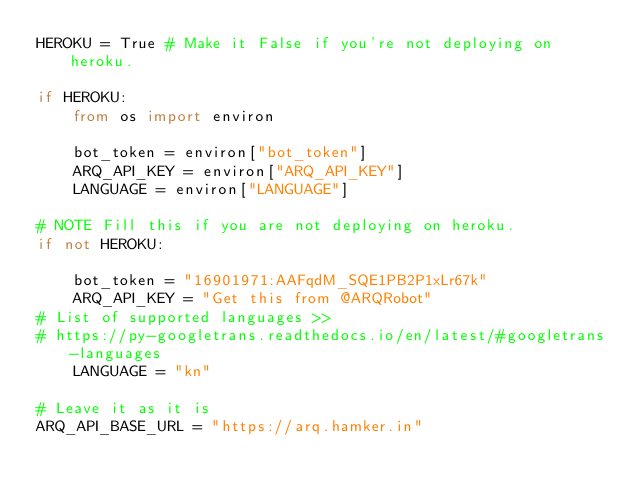<code> <loc_0><loc_0><loc_500><loc_500><_Python_>HEROKU = True # Make it False if you're not deploying on heroku.

if HEROKU:
    from os import environ

    bot_token = environ["bot_token"]
    ARQ_API_KEY = environ["ARQ_API_KEY"]
    LANGUAGE = environ["LANGUAGE"]

# NOTE Fill this if you are not deploying on heroku.
if not HEROKU:

    bot_token = "16901971:AAFqdM_SQE1PB2P1xLr67k"
    ARQ_API_KEY = "Get this from @ARQRobot"
# List of supported languages >>
# https://py-googletrans.readthedocs.io/en/latest/#googletrans-languages
    LANGUAGE = "kn"

# Leave it as it is
ARQ_API_BASE_URL = "https://arq.hamker.in"
</code> 